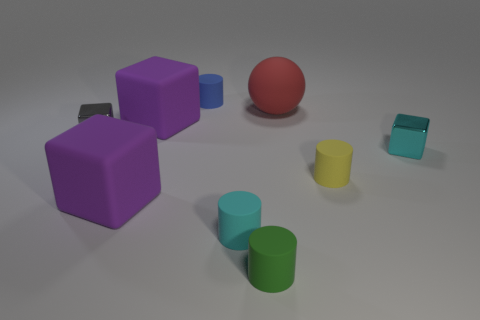Subtract all green matte cylinders. How many cylinders are left? 3 Subtract all blue spheres. How many purple blocks are left? 2 Subtract all cyan cylinders. How many cylinders are left? 3 Subtract 2 cylinders. How many cylinders are left? 2 Add 1 brown matte blocks. How many objects exist? 10 Subtract all cylinders. How many objects are left? 5 Subtract all cyan spheres. Subtract all gray cylinders. How many spheres are left? 1 Subtract all small red shiny balls. Subtract all cyan cubes. How many objects are left? 8 Add 5 cylinders. How many cylinders are left? 9 Add 7 cyan things. How many cyan things exist? 9 